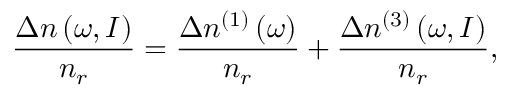Convert formula to latex. <formula><loc_0><loc_0><loc_500><loc_500>\frac { \Delta n \left ( \omega , I \right ) } { n _ { r } } = \frac { \Delta n ^ { ( 1 ) } \left ( \omega \right ) } { n _ { r } } + \frac { \Delta n ^ { ( 3 ) } \left ( \omega , I \right ) } { n _ { r } } ,</formula> 